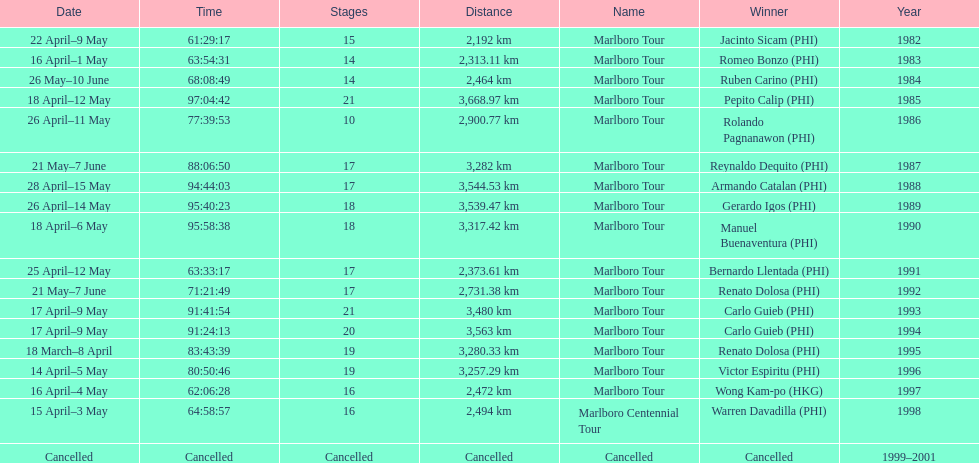How many marlboro tours did carlo guieb win? 2. 